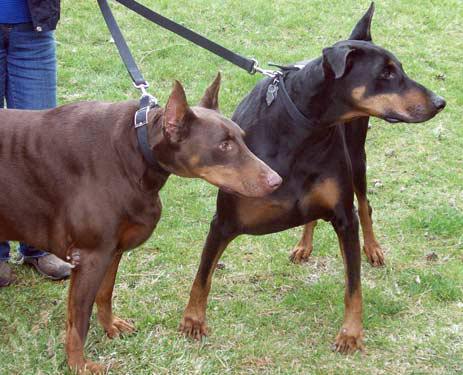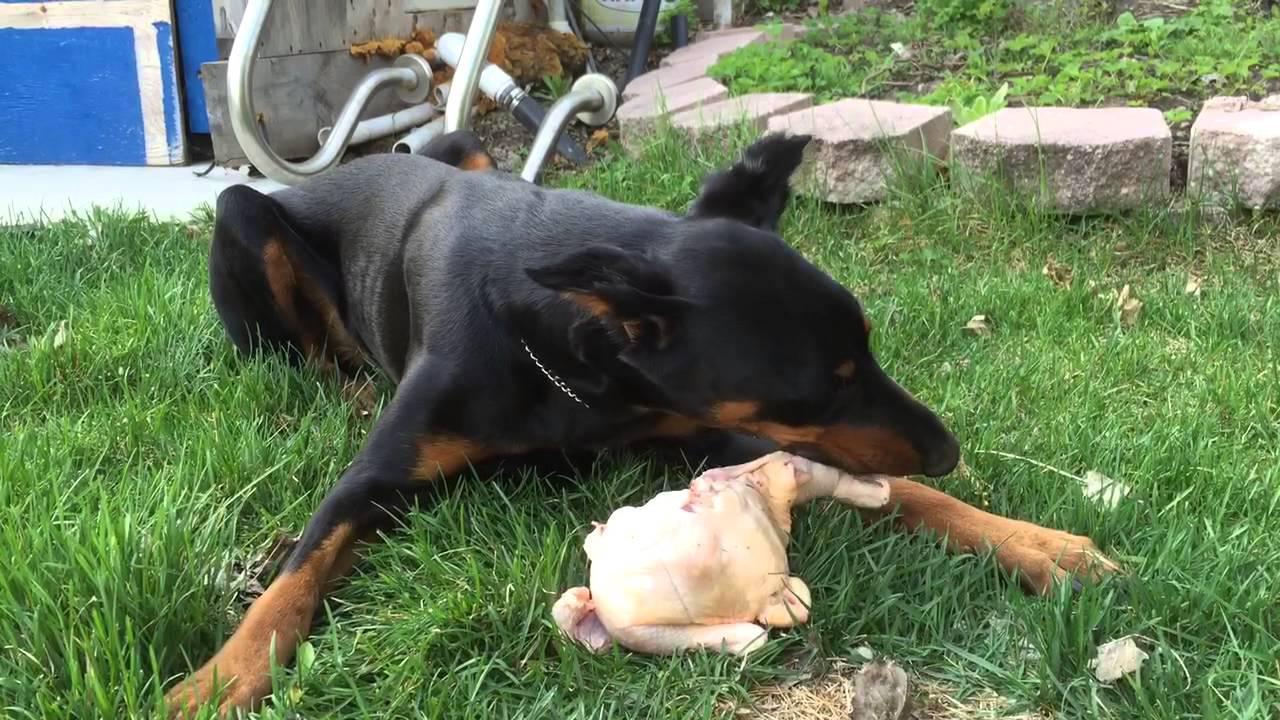The first image is the image on the left, the second image is the image on the right. Analyze the images presented: Is the assertion "One dog is laying in the grass." valid? Answer yes or no. Yes. The first image is the image on the left, the second image is the image on the right. Analyze the images presented: Is the assertion "The right image contains at least three dogs." valid? Answer yes or no. No. 